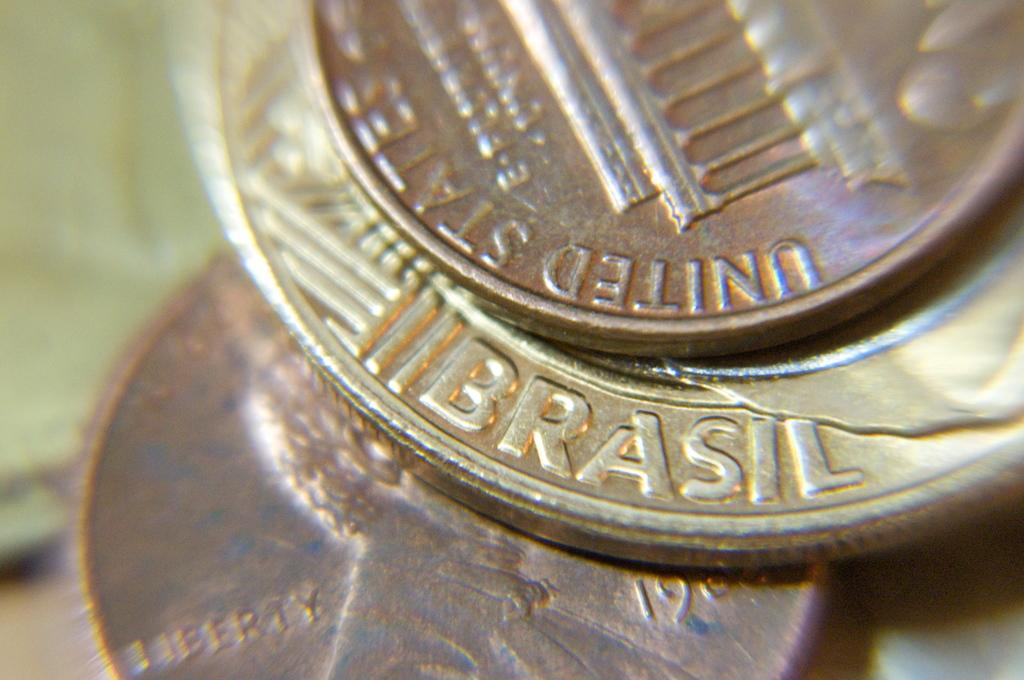<image>
Render a clear and concise summary of the photo. A coin that says "Brasil" on it sits with a United States coin. 